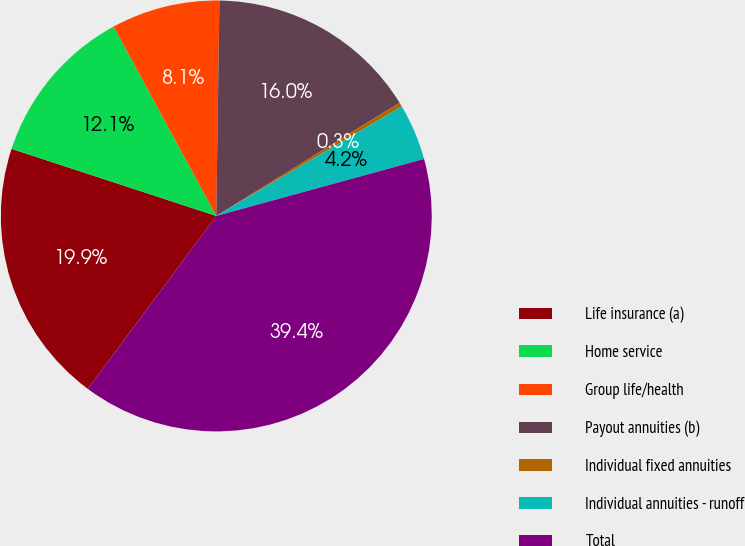Convert chart to OTSL. <chart><loc_0><loc_0><loc_500><loc_500><pie_chart><fcel>Life insurance (a)<fcel>Home service<fcel>Group life/health<fcel>Payout annuities (b)<fcel>Individual fixed annuities<fcel>Individual annuities - runoff<fcel>Total<nl><fcel>19.87%<fcel>12.05%<fcel>8.14%<fcel>15.96%<fcel>0.32%<fcel>4.23%<fcel>39.43%<nl></chart> 